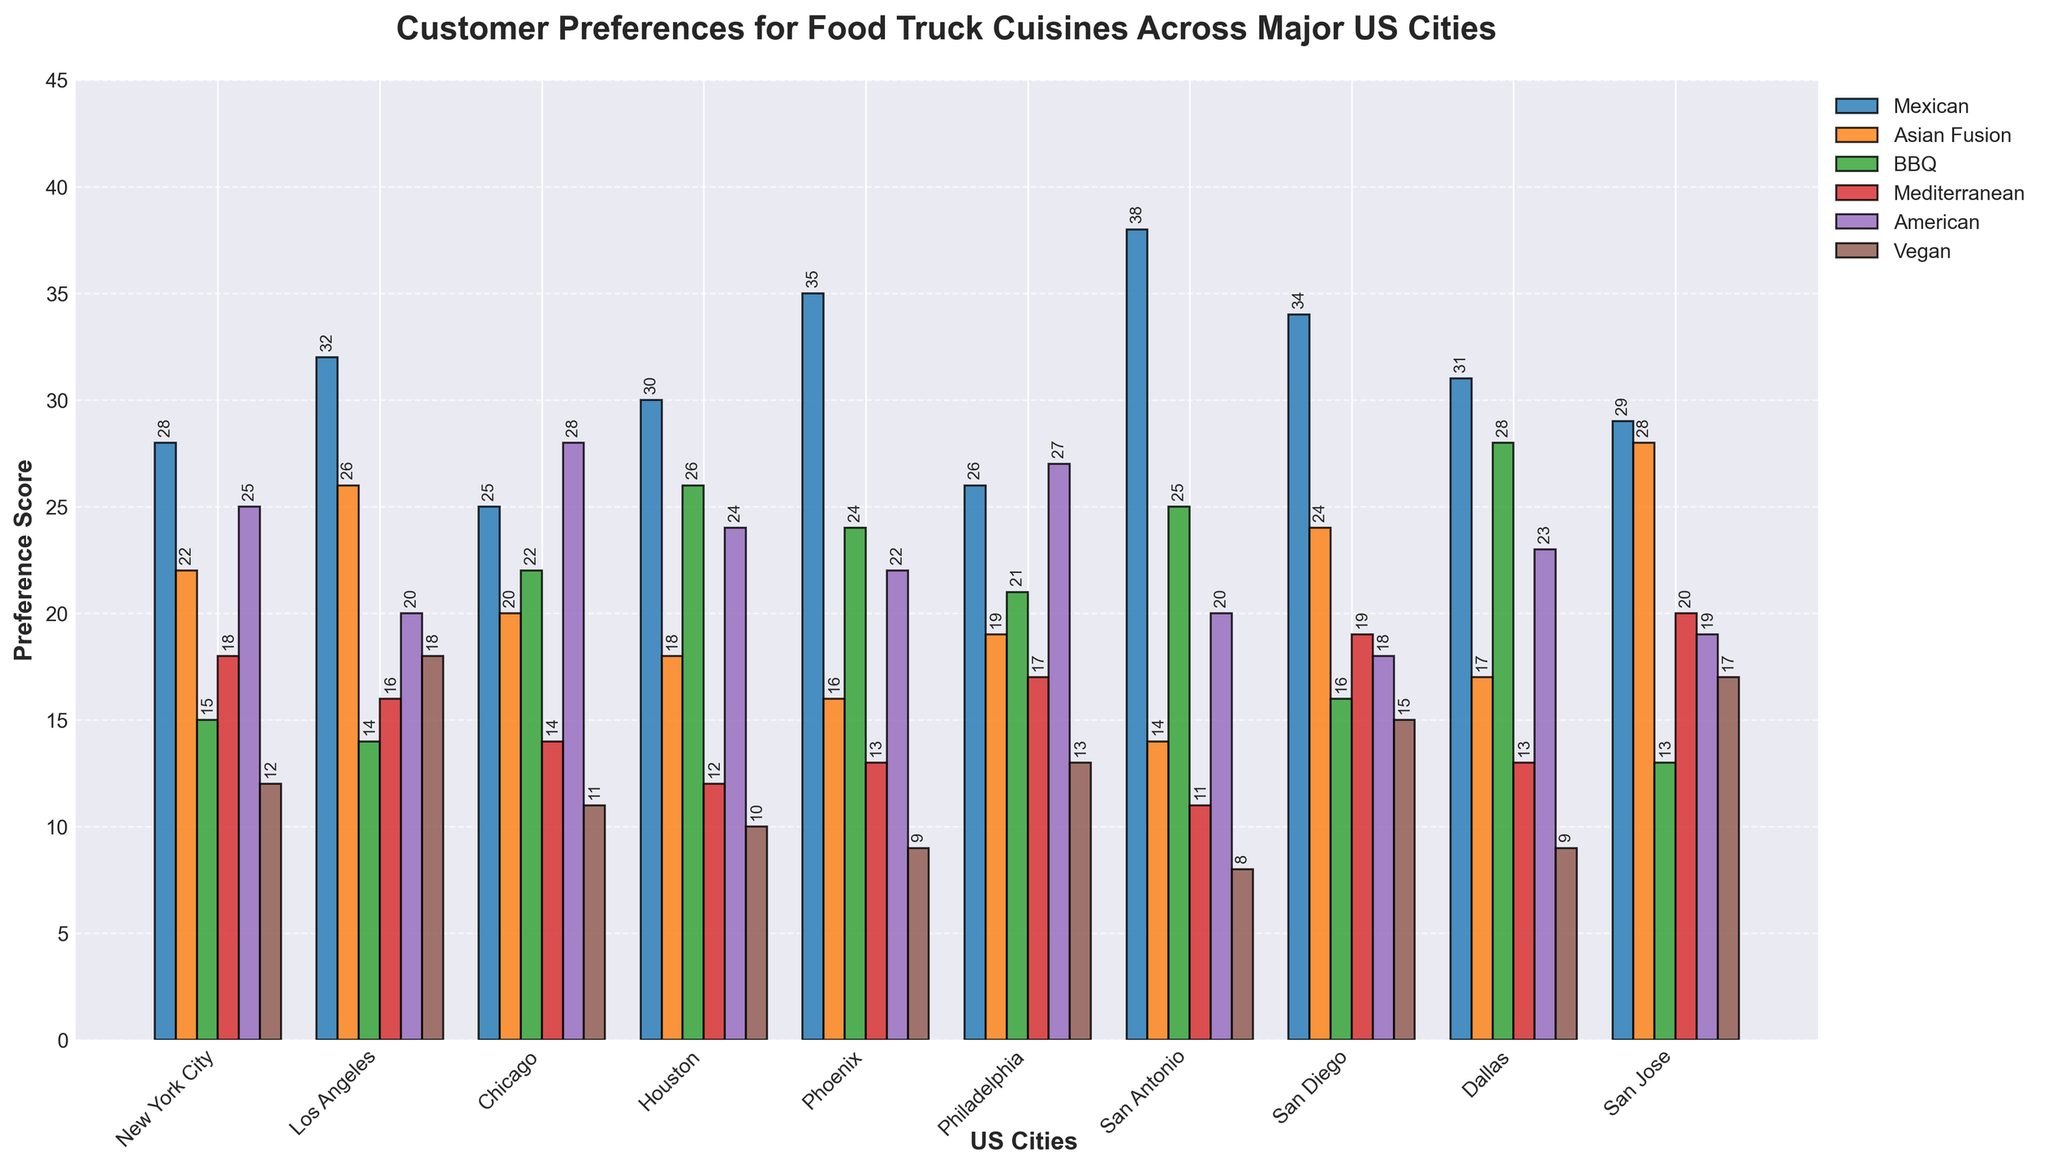Which city has the highest preference for Mexican cuisine? The preferences for Mexican cuisine in each city are displayed as the tallest bar in each group. San Antonio has the tallest bar for Mexican cuisine.
Answer: San Antonio What is the difference in preference scores for American cuisine between Chicago and San Diego? In the American cuisine category, check the height of the bars for Chicago and San Diego. Chicago’s bar is at 28, and San Diego’s bar is at 18. The difference is 28 - 18.
Answer: 10 Which cuisine has the least preference in the city of Houston? Look at the bars for each cuisine in Houston. The Vegan cuisine bar is the shortest at 10.
Answer: Vegan Which city shows the highest preference for Mediterranean cuisine? Inspect the bars representing Mediterranean cuisine across all cities. San Jose has the tallest bar for Mediterranean cuisine with a score of 20.
Answer: San Jose What is the average preference score for Asian Fusion cuisine across all cities? Sum the scores for Asian Fusion cuisine in all cities (22+26+20+18+16+19+14+24+17+28=204) and divide by the number of cities (10).
Answer: 20.4 Which city shows a greater preference for BBQ cuisine compared to Mediterranean cuisine? Compare the heights of the BBQ and Mediterranean cuisine bars within each city. For example, in Houston, BBQ has a score of 26 and Mediterranean has 12, so Houston shows a higher preference for BBQ.
Answer: Houston Among New York City, Los Angeles, and Chicago, which has the lowest preference for Vegan cuisine? Check the bars for Vegan cuisine in New York City (12), Los Angeles (18), and Chicago (11). Chicago has the lowest bar indicating a score of 11.
Answer: Chicago Which two cities have equal preference scores for American cuisine? Compare the heights of the American cuisine bars across all cities. Both New York City and Philadelphia have the same height bar indicating a score of 25.
Answer: New York City and Philadelphia What is the total preference score for BBQ cuisine across San Jose and Dallas? Add the BBQ preference scores of San Jose (13) and Dallas (28). The total is 13 + 28.
Answer: 41 